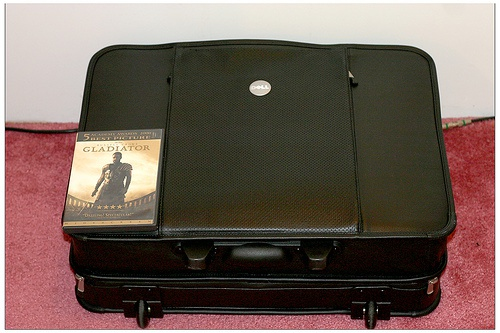Describe the objects in this image and their specific colors. I can see suitcase in black, white, gray, and darkgreen tones and book in white, gray, beige, and tan tones in this image. 